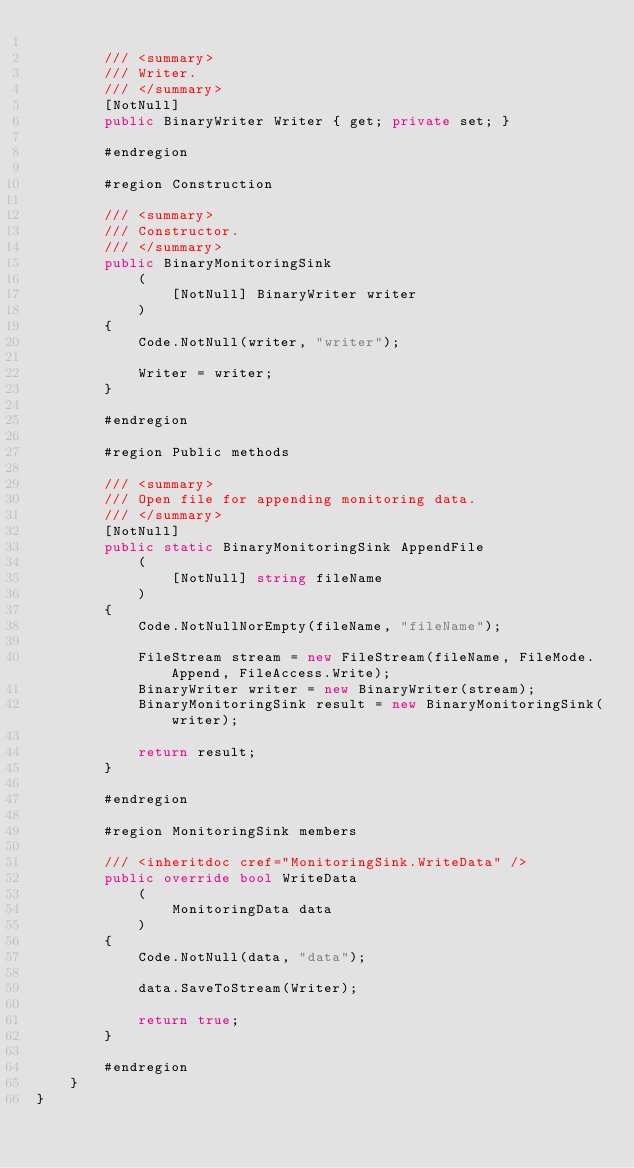<code> <loc_0><loc_0><loc_500><loc_500><_C#_>
        /// <summary>
        /// Writer.
        /// </summary>
        [NotNull]
        public BinaryWriter Writer { get; private set; }

        #endregion

        #region Construction

        /// <summary>
        /// Constructor.
        /// </summary>
        public BinaryMonitoringSink
            (
                [NotNull] BinaryWriter writer
            )
        {
            Code.NotNull(writer, "writer");

            Writer = writer;
        }

        #endregion

        #region Public methods

        /// <summary>
        /// Open file for appending monitoring data.
        /// </summary>
        [NotNull]
        public static BinaryMonitoringSink AppendFile
            (
                [NotNull] string fileName
            )
        {
            Code.NotNullNorEmpty(fileName, "fileName");

            FileStream stream = new FileStream(fileName, FileMode.Append, FileAccess.Write);
            BinaryWriter writer = new BinaryWriter(stream);
            BinaryMonitoringSink result = new BinaryMonitoringSink(writer);

            return result;
        }

        #endregion

        #region MonitoringSink members

        /// <inheritdoc cref="MonitoringSink.WriteData" />
        public override bool WriteData
            (
                MonitoringData data
            )
        {
            Code.NotNull(data, "data");

            data.SaveToStream(Writer);

            return true;
        }

        #endregion
    }
}
</code> 